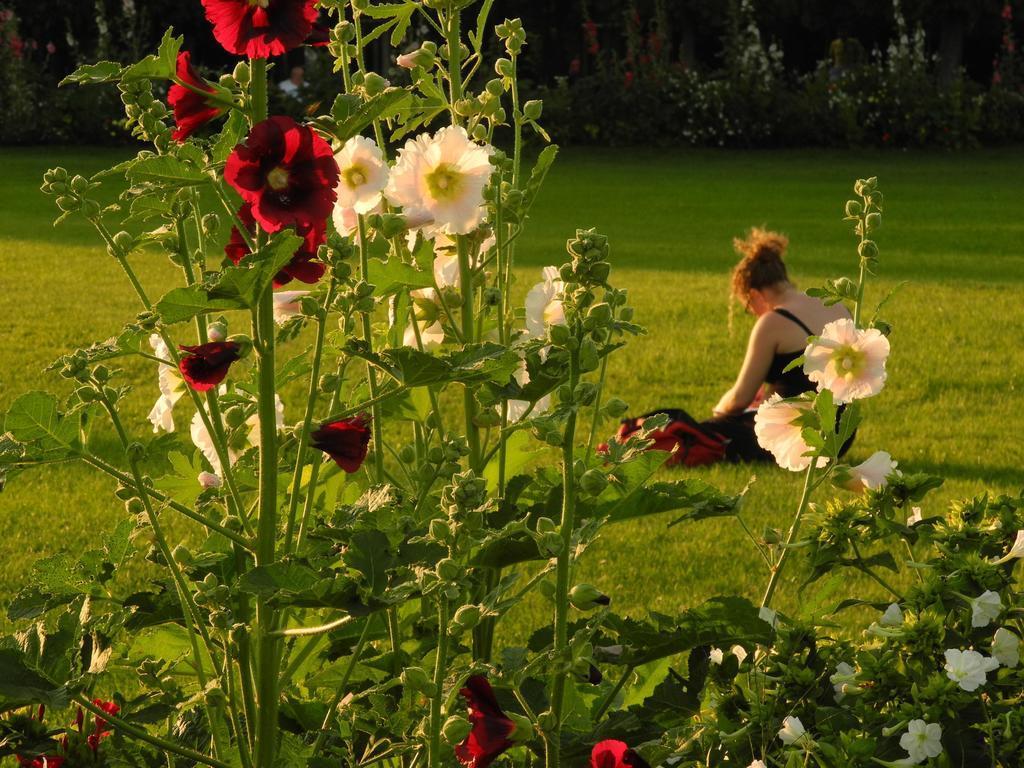Describe this image in one or two sentences. In this image we can see a group of plants and flowers. Behind the plants we can see a person and grass. In the background, we can see a group of plants. 